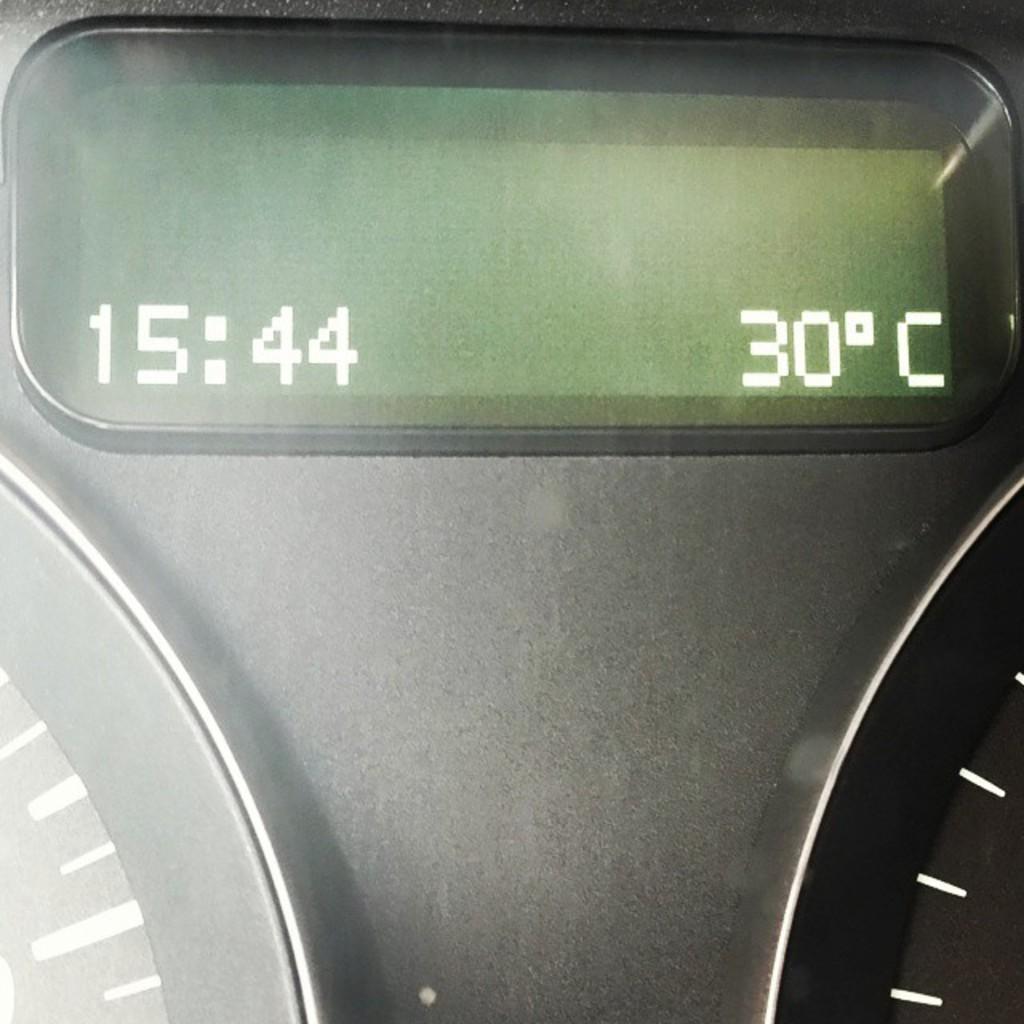What is the temperature shown here?
Make the answer very short. 30 degrees celsius. What time is shown on this display?
Offer a very short reply. 15:44. 